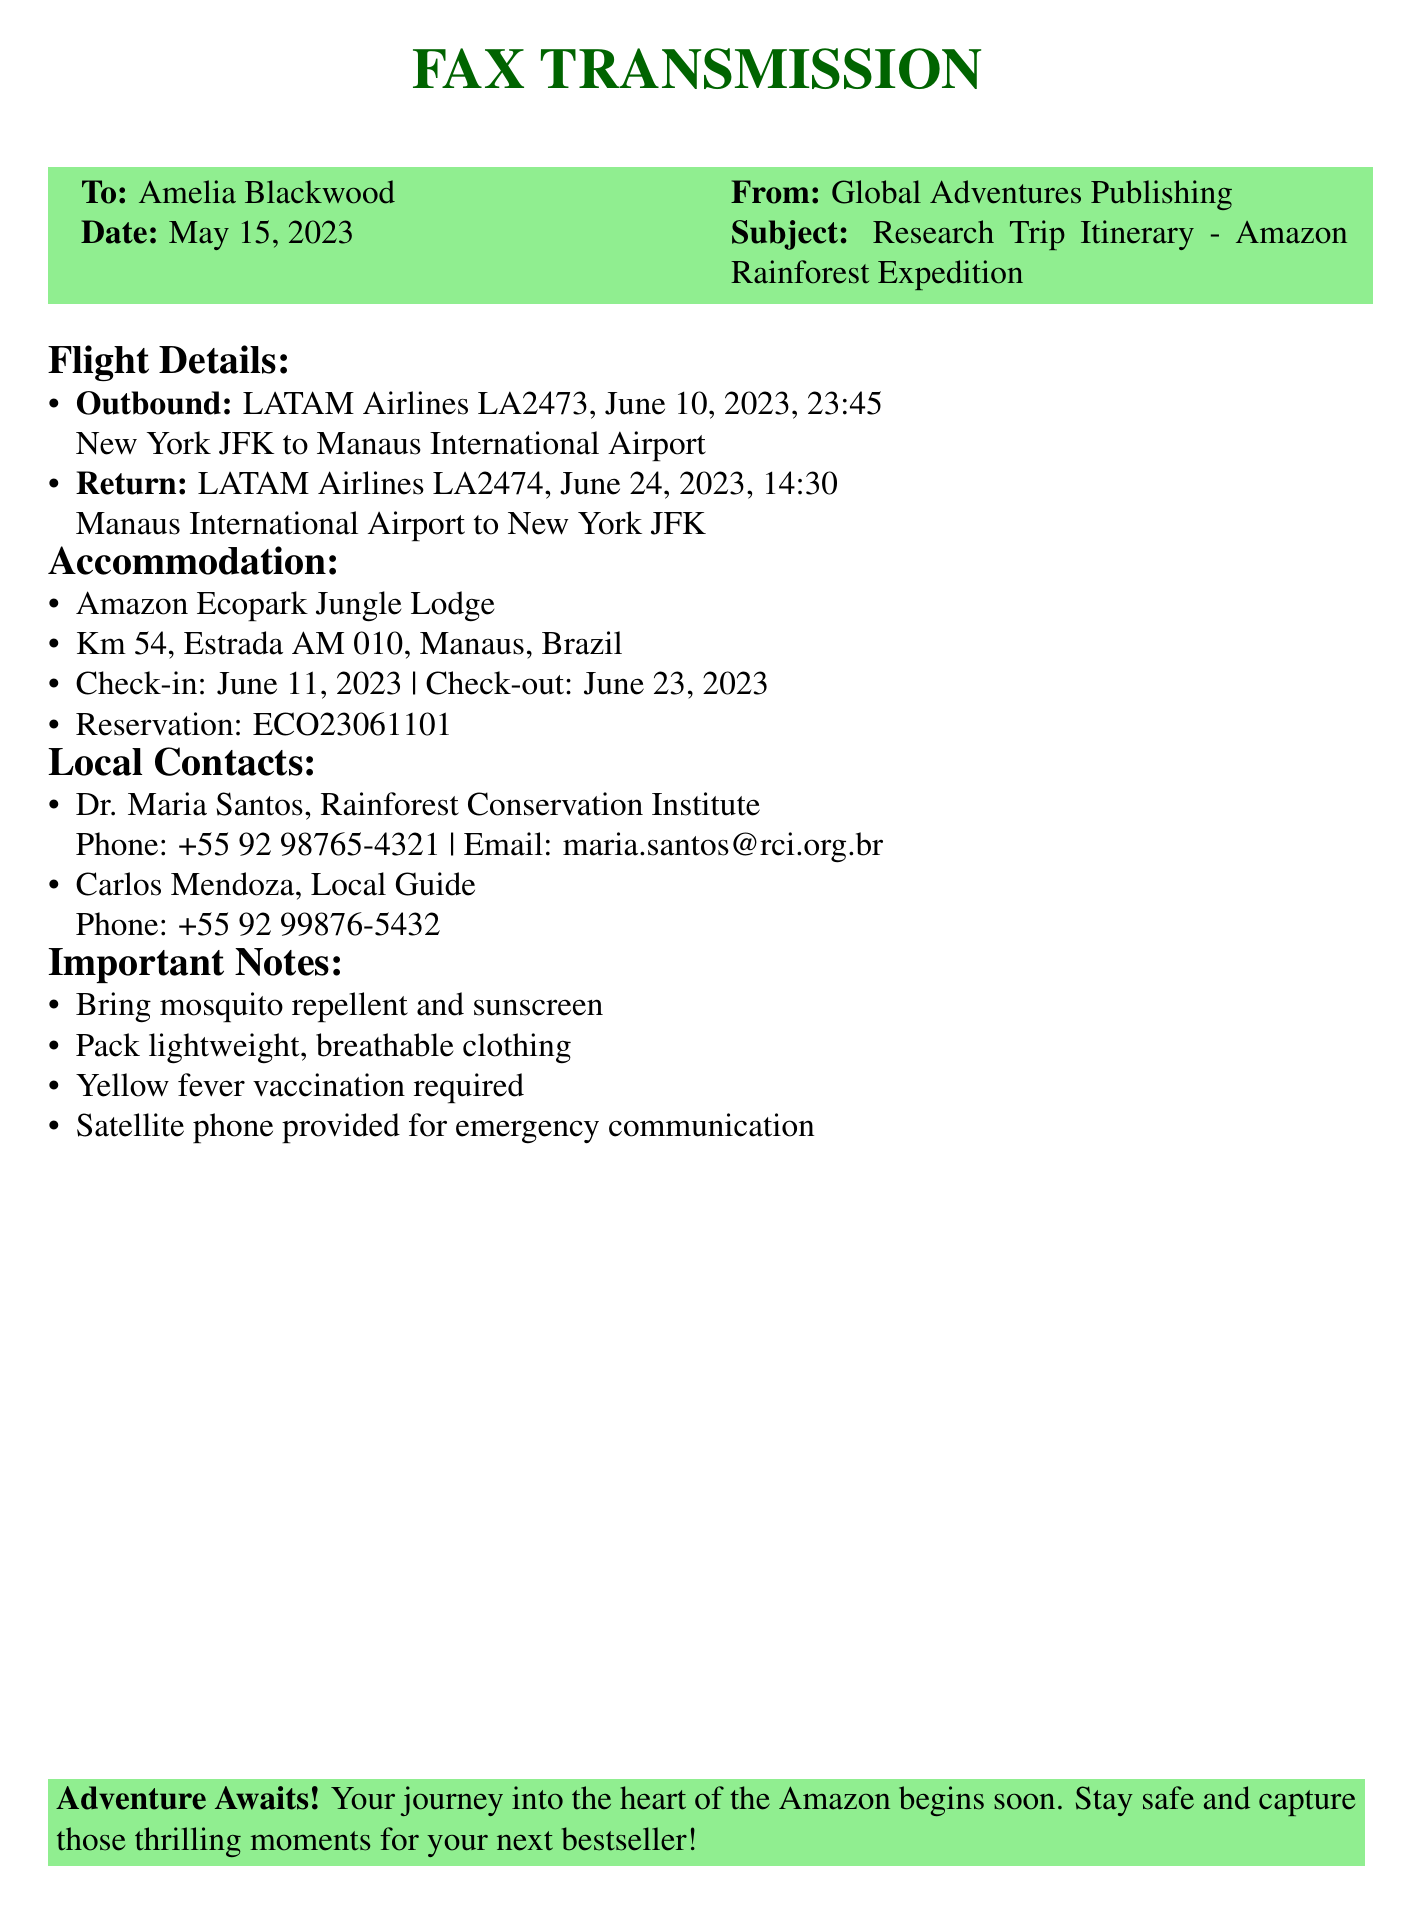What is the date of the outbound flight? The outbound flight is on June 10, 2023.
Answer: June 10, 2023 What is the name of the accommodation? The accommodation listed in the document is Amazon Ecopark Jungle Lodge.
Answer: Amazon Ecopark Jungle Lodge Who is the local contact from the Rainforest Conservation Institute? Dr. Maria Santos is the local contact from the Rainforest Conservation Institute.
Answer: Dr. Maria Santos What is the check-out date from the lodge? The check-out date is mentioned as June 23, 2023.
Answer: June 23, 2023 Which airline is used for the return flight? LATAM Airlines is the airline used for the return flight.
Answer: LATAM Airlines How long is the research trip? The trip lasts from June 10, 2023, to June 24, 2023, which is 14 days.
Answer: 14 days What is included for emergency communication? A satellite phone is provided for emergency communication.
Answer: Satellite phone What important item is required regarding health? A yellow fever vaccination is required.
Answer: Yellow fever vaccination When will the research trip start? The research trip will start on June 10, 2023.
Answer: June 10, 2023 